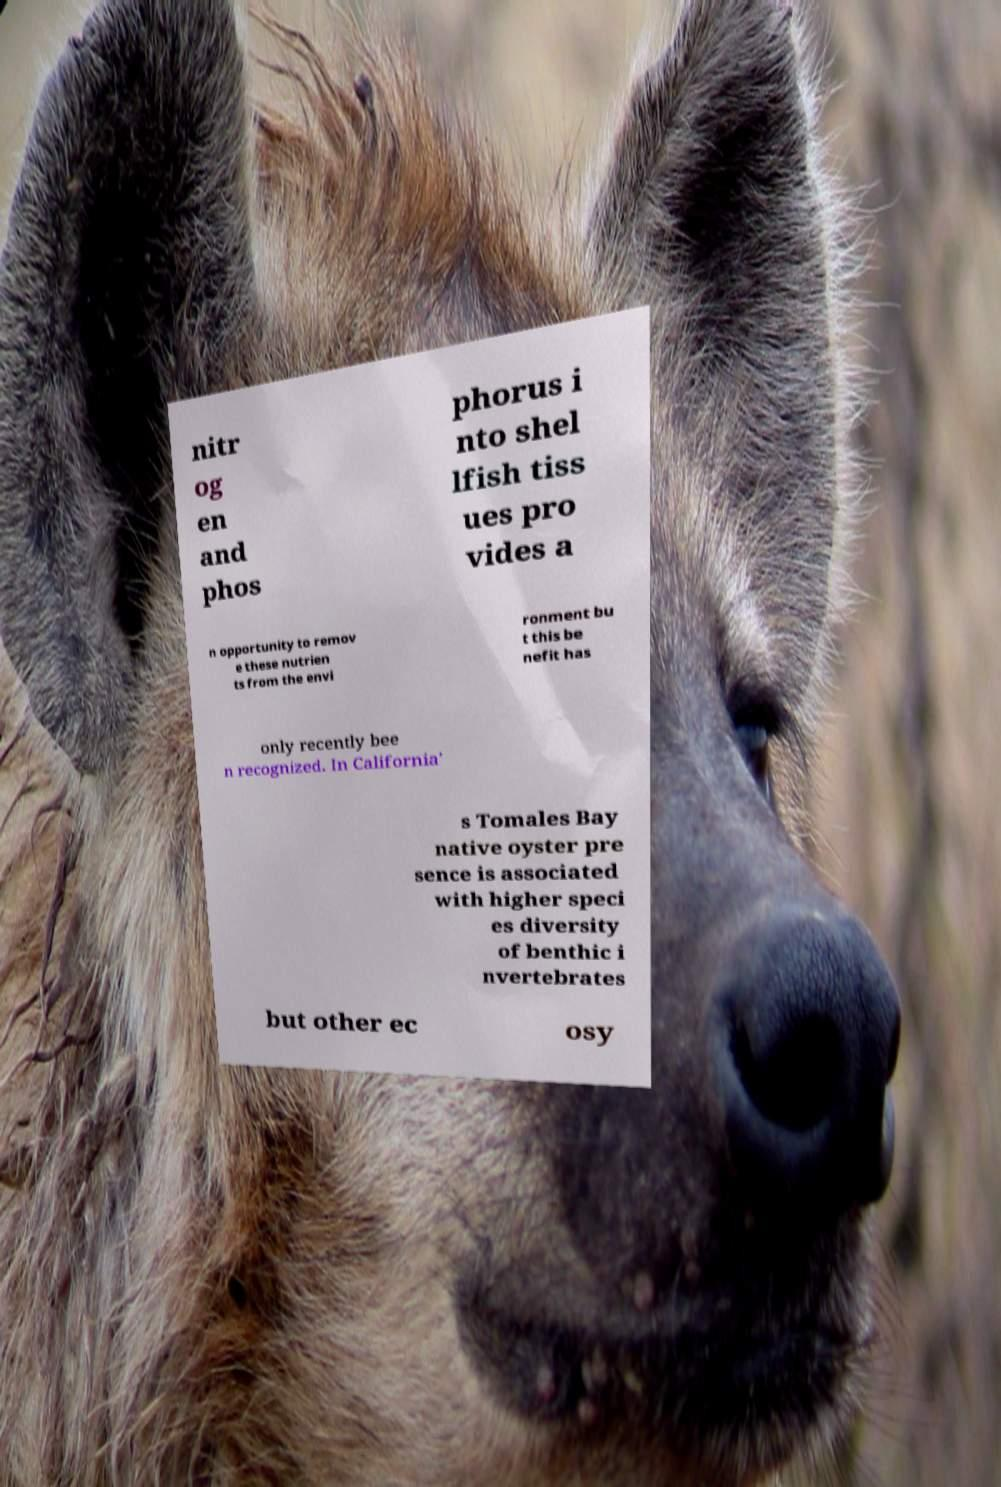Can you read and provide the text displayed in the image?This photo seems to have some interesting text. Can you extract and type it out for me? nitr og en and phos phorus i nto shel lfish tiss ues pro vides a n opportunity to remov e these nutrien ts from the envi ronment bu t this be nefit has only recently bee n recognized. In California' s Tomales Bay native oyster pre sence is associated with higher speci es diversity of benthic i nvertebrates but other ec osy 